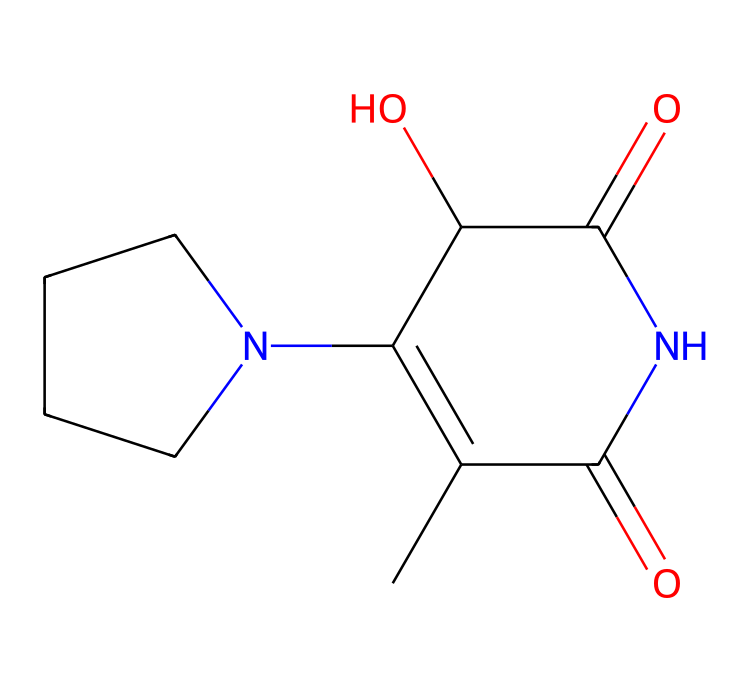What is the molecular formula of this compound? To determine the molecular formula, count the number of each type of atom in the SMILES. The structure indicates there are 10 Carbon (C), 15 Hydrogen (H), 2 Nitrogen (N), and 5 Oxygen (O) atoms. Therefore, the molecular formula is C10H15N2O5.
Answer: C10H15N2O5 How many rings are present in this chemical structure? By analyzing the SMILES, the "C1" indicates the start of a ring and "C1" later shows its closure. Counted, there's one ring in the structure.
Answer: 1 What type of drug classification does this compound belong to? Insulin is a hormone used for managing diabetes, and it is classified as a peptide hormone based on its structure which includes amino acids.
Answer: peptide hormone What functional groups are present in this compound? Review the structure to identify functional groups: the presence of -NH (amino) group, -CO (carbonyl) groups, and -OH (hydroxyl) groups can be distinguished. Therefore, it contains an amide, carbonyl, and hydroxyl functional groups.
Answer: amide, carbonyl, hydroxyl What is the key pharmacological action of this chemical? Insulin primarily acts by facilitating glucose uptake into cells, lowering blood glucose levels, and promoting glycogen synthesis in the liver. Therefore, its key pharmacological action is to reduce blood sugar levels.
Answer: reduces blood sugar levels Is this compound suitable for oral administration? Insulin is usually not administered orally because it would be degraded in the digestive system. Therefore, it is typically delivered via injection.
Answer: no 